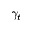Convert formula to latex. <formula><loc_0><loc_0><loc_500><loc_500>\gamma _ { t }</formula> 